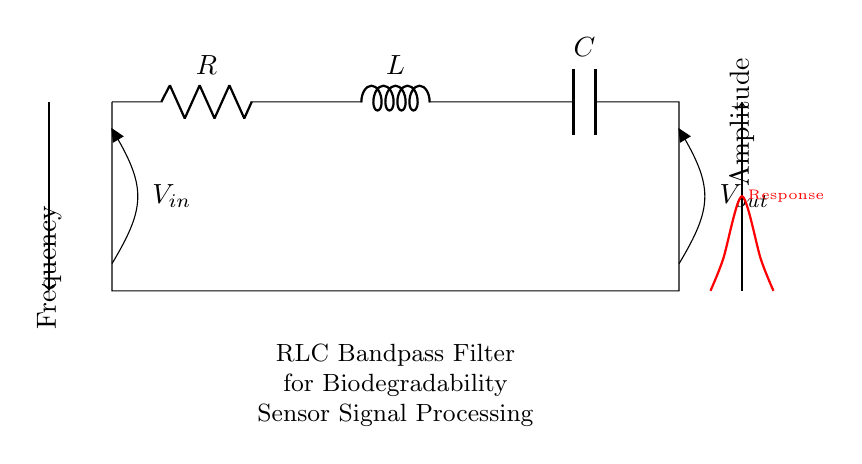What are the components in this circuit? The circuit diagram shows three components: a resistor, an inductor, and a capacitor, which are connected in series.
Answer: Resistor, inductor, capacitor What is the role of the resistor in this filter? The resistor in a bandpass filter helps to control the overall resistance of the circuit, impacting the damping factor and bandwidth, hence influencing the filter's frequency response.
Answer: Control bandwidth What does \( V_{in} \) represent? \( V_{in} \) is the input voltage, indicating the voltage applied to the circuit before it undergoes filtering by the RLC components.
Answer: Input voltage Identify the output voltage in the circuit. \( V_{out} \) represents the voltage across the output, which is the resulting voltage after the filtering process.
Answer: Output voltage What type of filter is represented by this circuit? This circuit represents a bandpass filter, allowing signals within a certain frequency range to pass while attenuating frequencies outside that range.
Answer: Bandpass filter Why might this filter be useful in biodegradability sensors? The bandpass filter allows specific frequency ranges associated with the characteristics of biodegradable materials to be selectively amplified for better detection and analysis in sensors.
Answer: Signal amplification for detection 